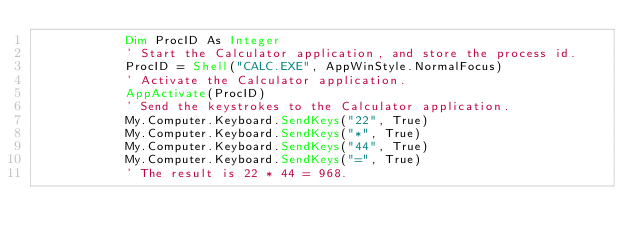Convert code to text. <code><loc_0><loc_0><loc_500><loc_500><_VisualBasic_>            Dim ProcID As Integer
            ' Start the Calculator application, and store the process id.
            ProcID = Shell("CALC.EXE", AppWinStyle.NormalFocus)
            ' Activate the Calculator application.
            AppActivate(ProcID)
            ' Send the keystrokes to the Calculator application.
            My.Computer.Keyboard.SendKeys("22", True)
            My.Computer.Keyboard.SendKeys("*", True)
            My.Computer.Keyboard.SendKeys("44", True)
            My.Computer.Keyboard.SendKeys("=", True)
            ' The result is 22 * 44 = 968.</code> 